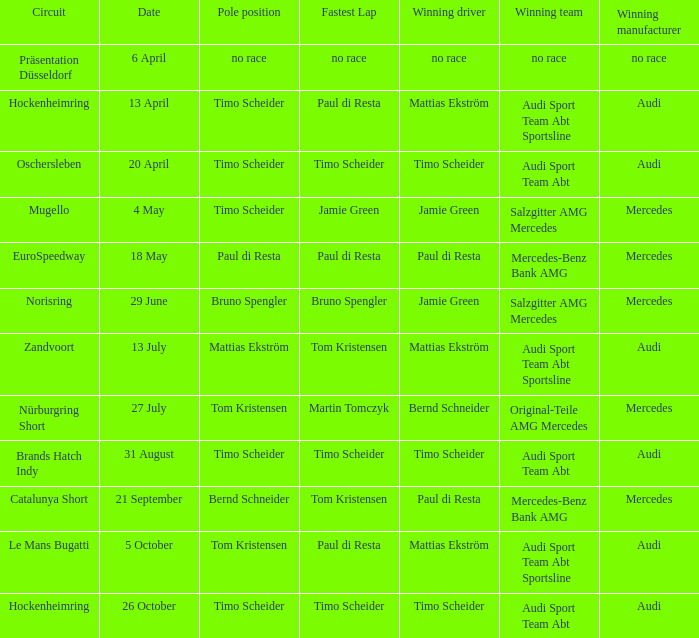Who is the triumphant racer at the oschersleben track with timo scheider as the pole position? Timo Scheider. 